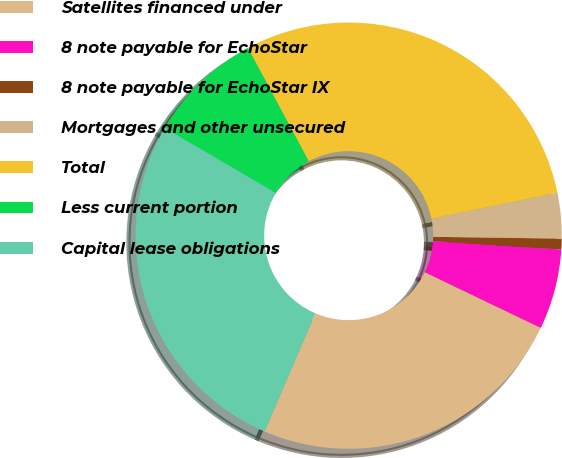Convert chart. <chart><loc_0><loc_0><loc_500><loc_500><pie_chart><fcel>Satellites financed under<fcel>8 note payable for EchoStar<fcel>8 note payable for EchoStar IX<fcel>Mortgages and other unsecured<fcel>Total<fcel>Less current portion<fcel>Capital lease obligations<nl><fcel>24.33%<fcel>6.09%<fcel>0.81%<fcel>3.45%<fcel>29.61%<fcel>8.73%<fcel>26.97%<nl></chart> 